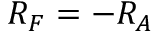Convert formula to latex. <formula><loc_0><loc_0><loc_500><loc_500>R _ { F } = - R _ { A }</formula> 